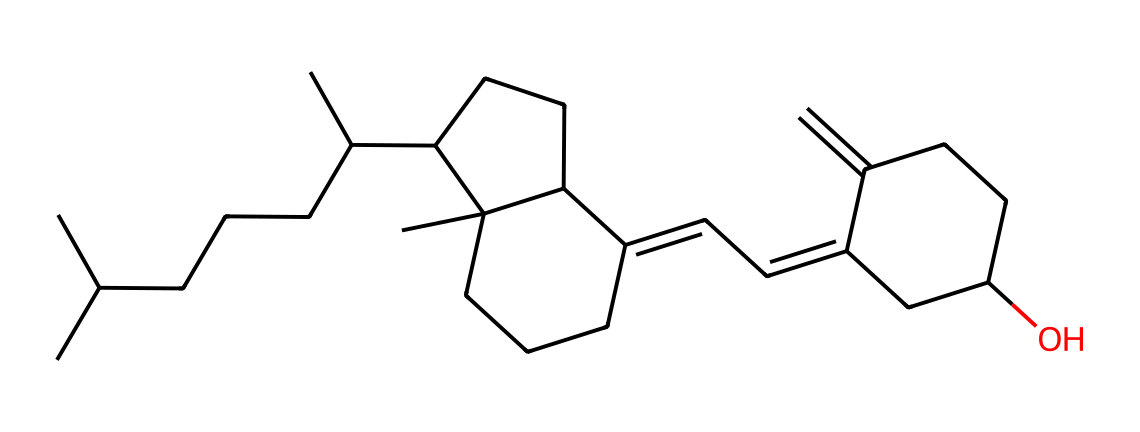What is the molecular formula of vitamin D3 based on the structure? To determine the molecular formula from the SMILES representation, one needs to identify the number of carbon (C), hydrogen (H), and oxygen (O) atoms. From the SMILES, there are 27 carbon atoms, 44 hydrogen atoms, and 1 oxygen atom. Therefore, the molecular formula for vitamin D3 is C27H44O.
Answer: C27H44O How many rings are present in the structure of vitamin D3? By examining the chemical structure, we can see that there are two distinct cyclic components within the molecule, which are the cyclohexane rings. Counting these gives a total of two rings in the structure.
Answer: 2 What type of vitamin is indicated by this molecule? This molecule is a vitamin derivative specifically associated with the fat-soluble class of vitamins, particularly vitamin D. The structure shown is characteristic of vitamin D3, also known as cholecalciferol.
Answer: vitamin D Which part of this structure is responsible for its sunlight synthesis? The presence of the double bonds in the structure, particularly in the B-ring portion, is significant in converting 7-dehydrocholesterol in the skin to vitamin D3 upon exposure to UVB light, facilitating its production.
Answer: double bonds How many double bonds are present in vitamin D3? By carefully analyzing the structure, you would count the double bonds, which are typically represented between carbon atoms. In the structure for vitamin D3, there are two double bonds present.
Answer: 2 What is a primary function of vitamin D3 in the body? Vitamin D3 plays a critical role in the regulation of calcium and phosphate in the body, helping to maintain bone health and overall bone metabolism. This function is fundamental to its biological importance.
Answer: calcium regulation 